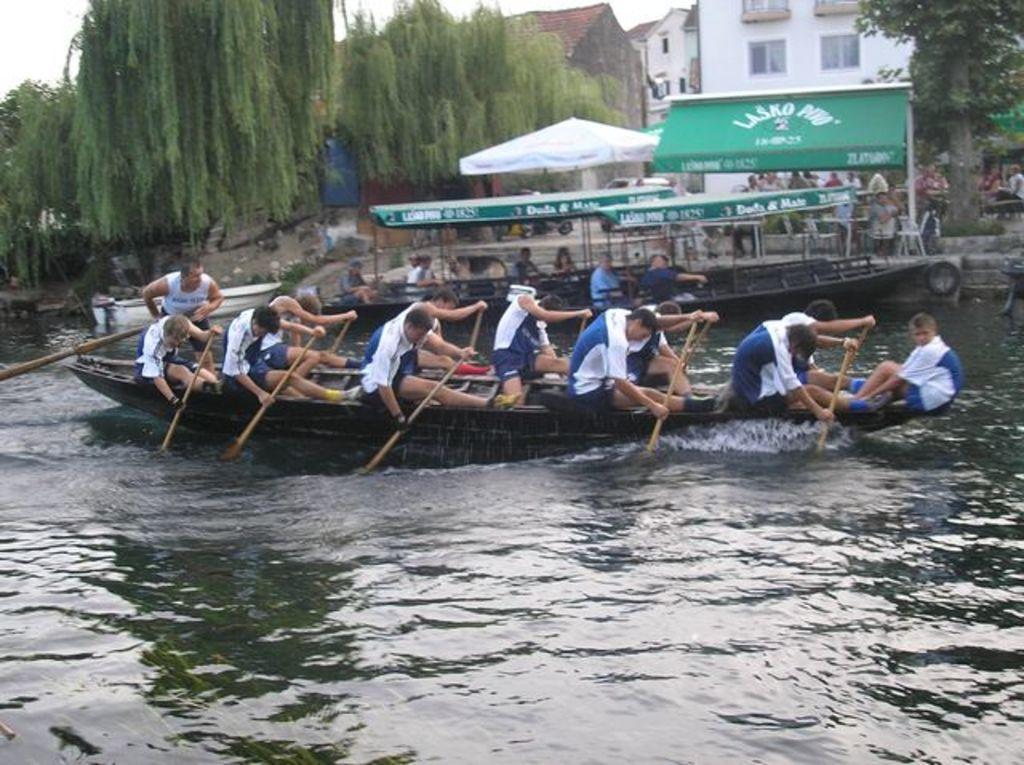Could you give a brief overview of what you see in this image? In this picture we can see the buildings, windows, trees, people, tents, chairs. In this picture we can see the water, people and the boats. We can see few people are holding the paddles. 